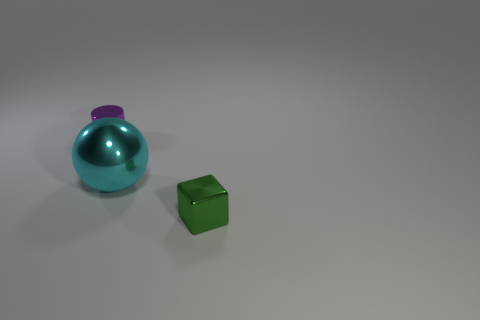Add 1 spheres. How many objects exist? 4 Subtract all spheres. How many objects are left? 2 Add 1 cyan shiny objects. How many cyan shiny objects are left? 2 Add 3 purple rubber things. How many purple rubber things exist? 3 Subtract 0 gray balls. How many objects are left? 3 Subtract all red shiny balls. Subtract all big metal spheres. How many objects are left? 2 